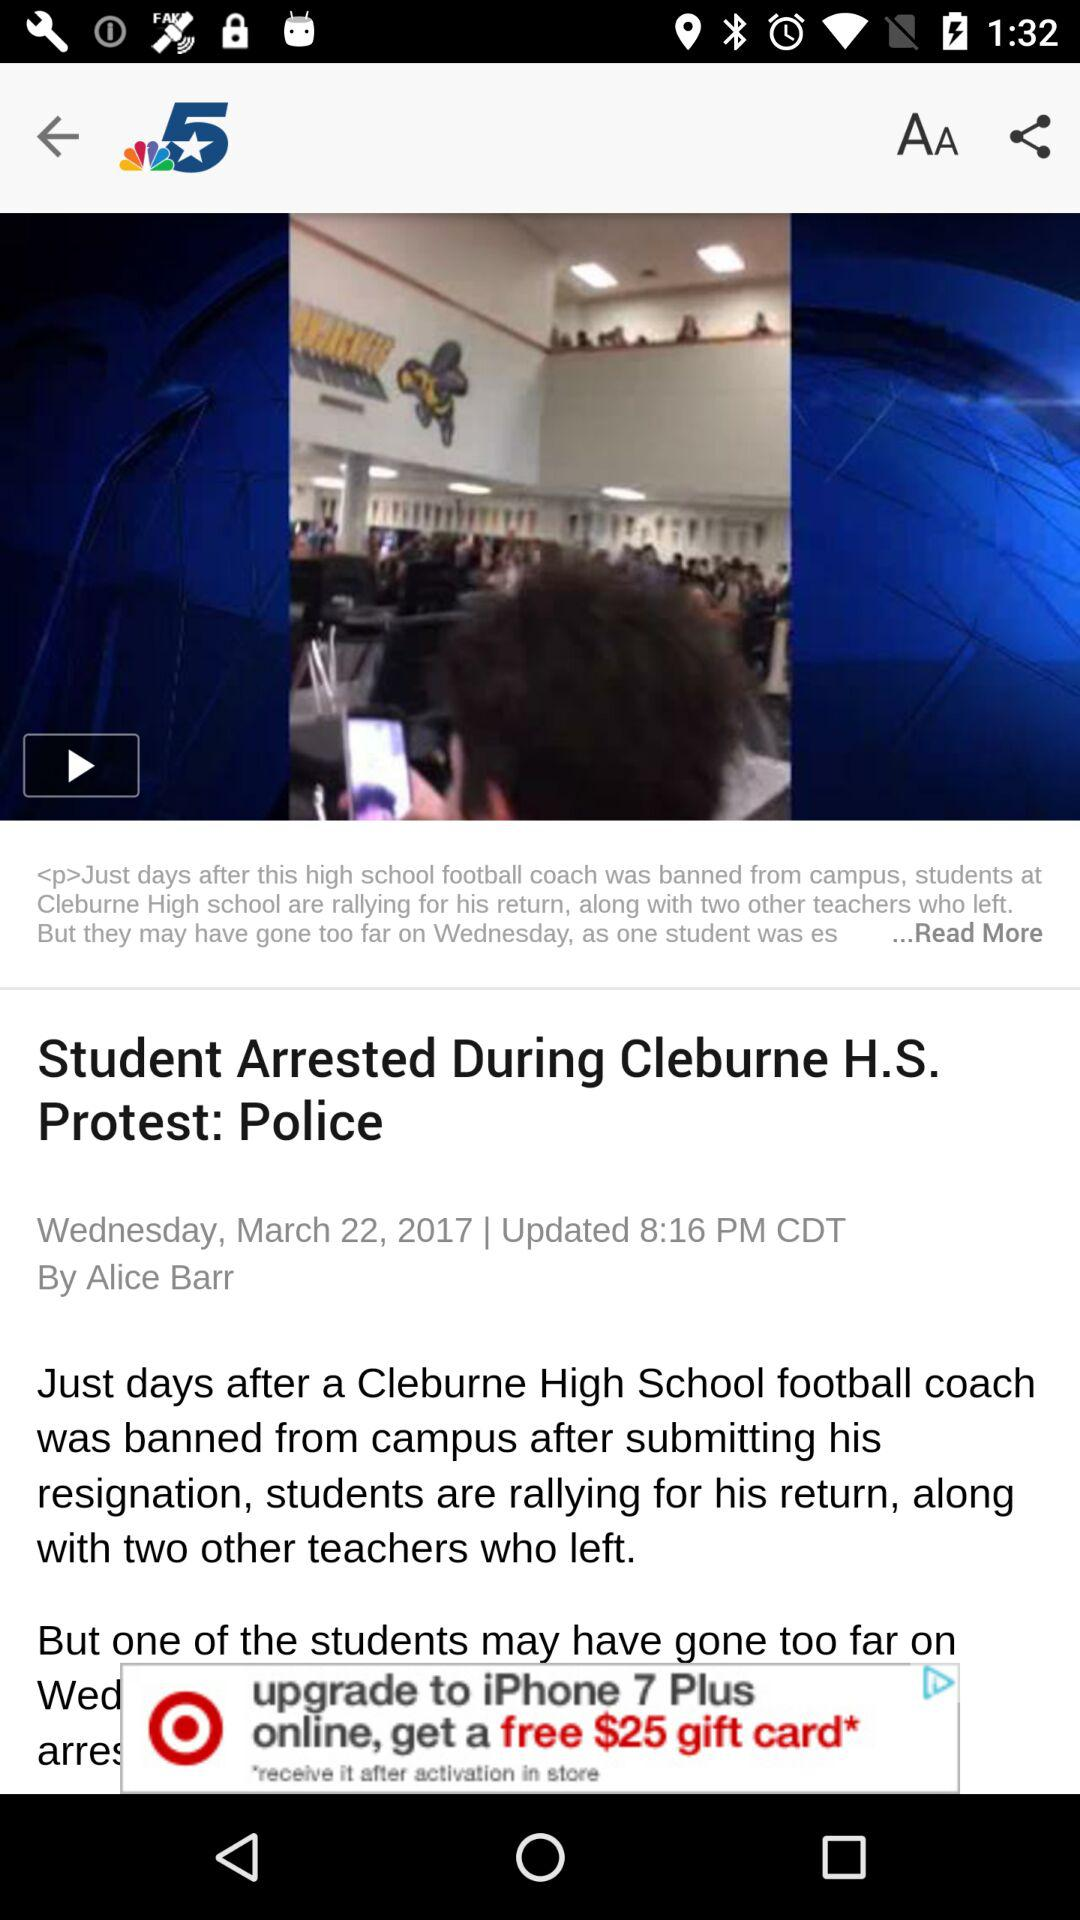What is the updated time of news? The updated time of news is 8:16 PM. 